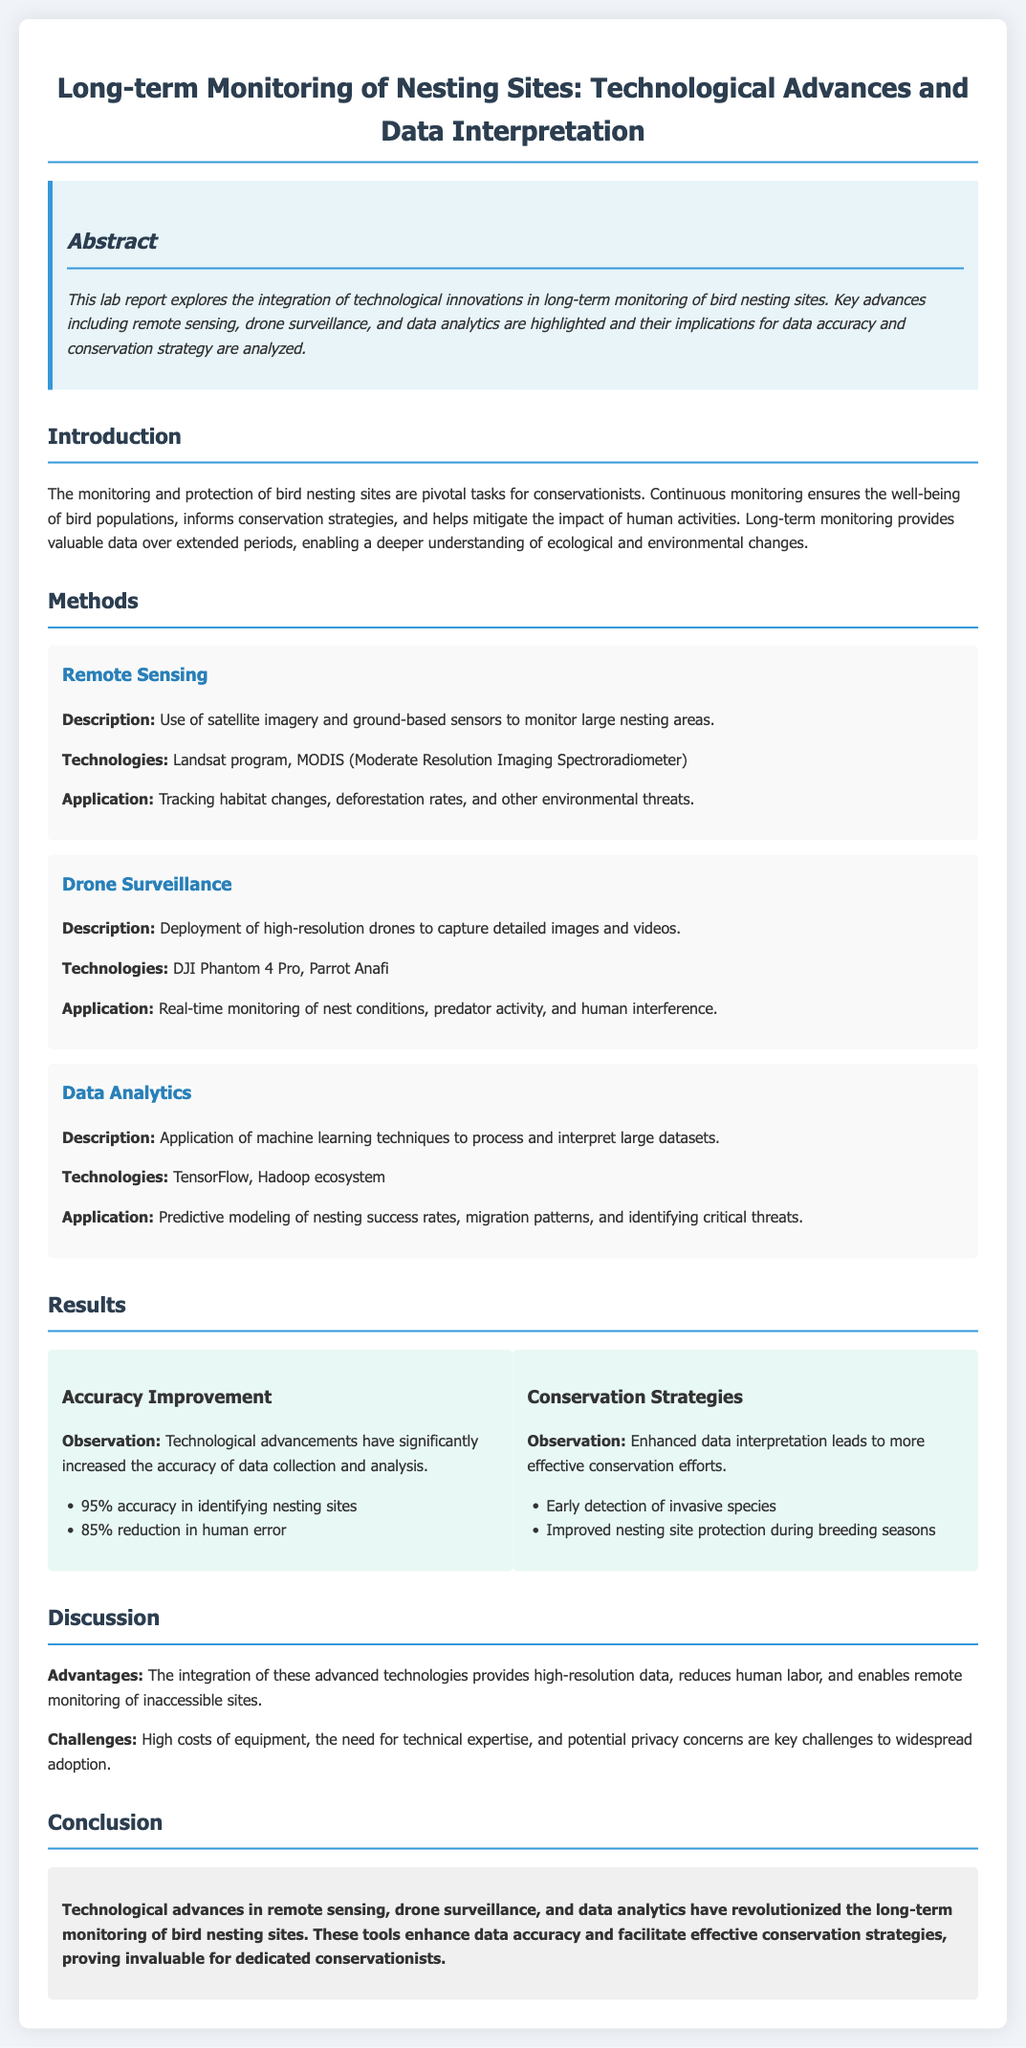What is the primary focus of the lab report? The primary focus is on the integration of technological innovations in long-term monitoring of bird nesting sites.
Answer: integration of technological innovations Which technology is used for remote sensing? Remote sensing technologies include the Landsat program and MODIS.
Answer: Landsat program, MODIS What is the accuracy percentage in identifying nesting sites? The document states that the accuracy in identifying nesting sites is 95%.
Answer: 95% What is one of the advantages of using advanced technologies? One advantage mentioned is high-resolution data.
Answer: high-resolution data What challenge is mentioned regarding the adoption of new technologies? A key challenge mentioned is the high costs of equipment.
Answer: high costs of equipment What improvement is noted in relation to human error? The report states there is an 85% reduction in human error.
Answer: 85% reduction in human error What is one application of drone surveillance? An application of drone surveillance is real-time monitoring of nest conditions.
Answer: real-time monitoring of nest conditions What does the conclusion suggest about the implications of technological advances? It suggests that these tools enhance data accuracy and facilitate effective conservation strategies.
Answer: enhance data accuracy and facilitate effective conservation strategies 